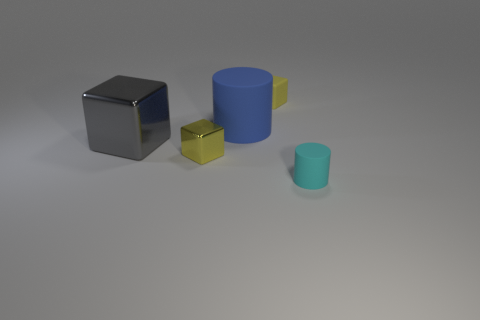What material is the other cube that is the same size as the yellow matte block?
Offer a terse response. Metal. There is a big metal cube; what number of rubber objects are behind it?
Make the answer very short. 2. There is a object behind the blue matte object; is it the same shape as the gray metal object?
Your response must be concise. Yes. Are there any blue rubber objects of the same shape as the small cyan matte object?
Offer a very short reply. Yes. There is a cube that is the same color as the small shiny object; what is it made of?
Provide a short and direct response. Rubber. There is a yellow thing in front of the small matte object that is to the left of the small cyan cylinder; what shape is it?
Ensure brevity in your answer.  Cube. What number of tiny cyan cylinders are made of the same material as the gray block?
Offer a very short reply. 0. What is the color of the cube that is the same material as the big blue object?
Offer a terse response. Yellow. How big is the cylinder right of the tiny yellow block to the right of the tiny yellow shiny block that is left of the blue thing?
Offer a very short reply. Small. Are there fewer big matte cylinders than red metal balls?
Your response must be concise. No. 